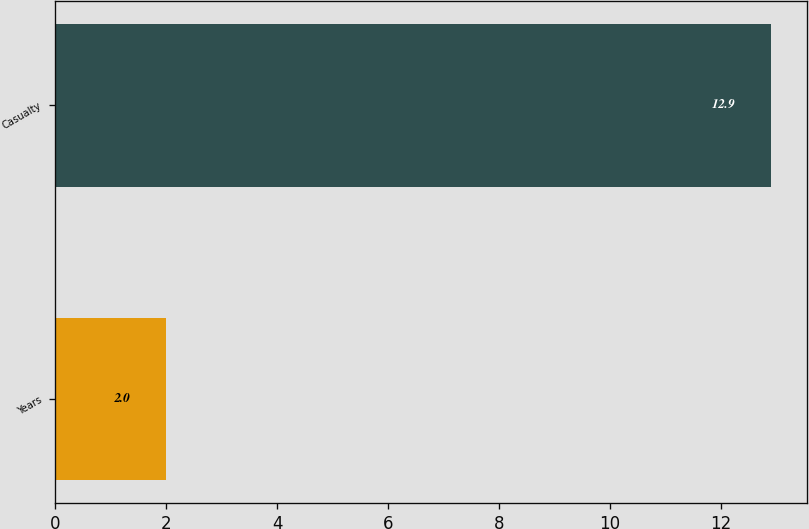Convert chart to OTSL. <chart><loc_0><loc_0><loc_500><loc_500><bar_chart><fcel>Years<fcel>Casualty<nl><fcel>2<fcel>12.9<nl></chart> 